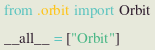Convert code to text. <code><loc_0><loc_0><loc_500><loc_500><_Python_>from .orbit import Orbit

__all__ = ["Orbit"]
</code> 